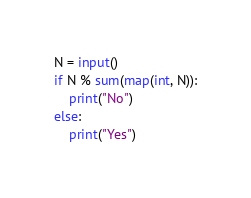Convert code to text. <code><loc_0><loc_0><loc_500><loc_500><_Python_>N = input()
if N % sum(map(int, N)):
    print("No")
else:
    print("Yes")</code> 